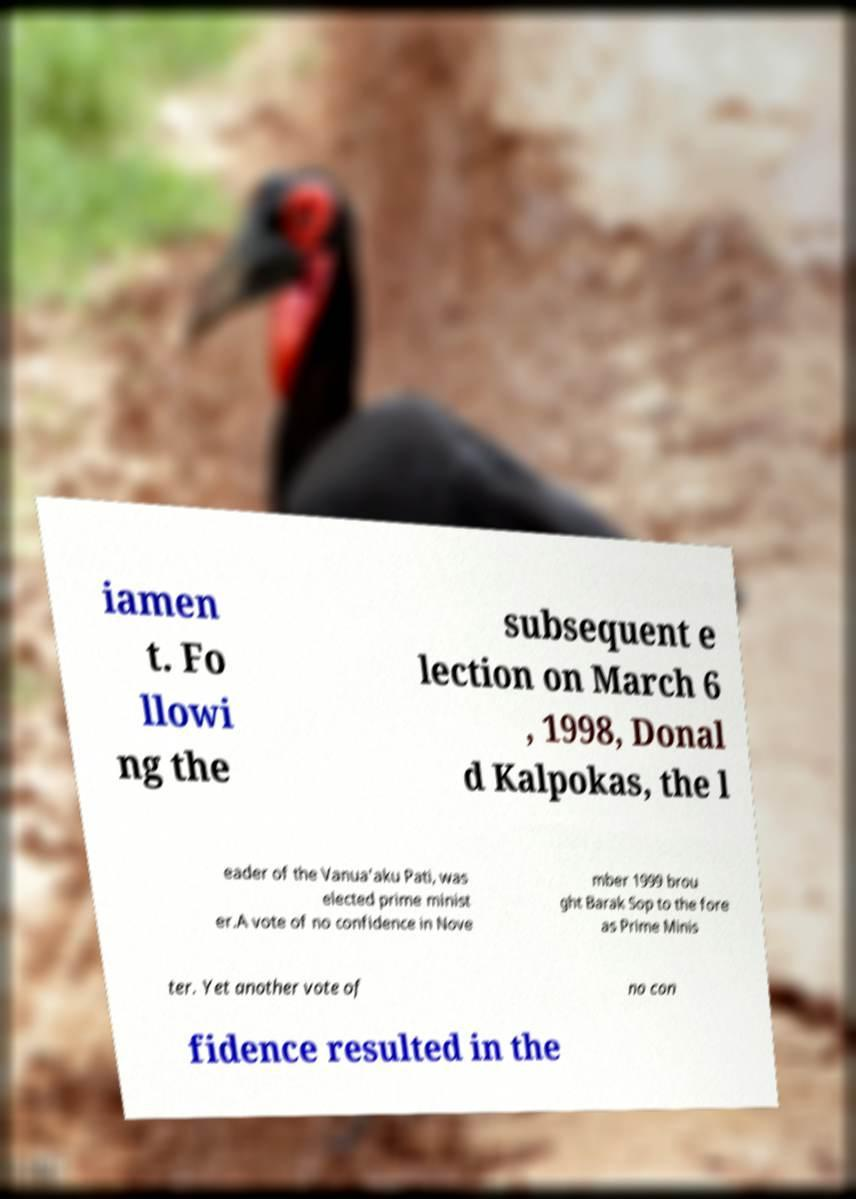For documentation purposes, I need the text within this image transcribed. Could you provide that? iamen t. Fo llowi ng the subsequent e lection on March 6 , 1998, Donal d Kalpokas, the l eader of the Vanua'aku Pati, was elected prime minist er.A vote of no confidence in Nove mber 1999 brou ght Barak Sop to the fore as Prime Minis ter. Yet another vote of no con fidence resulted in the 